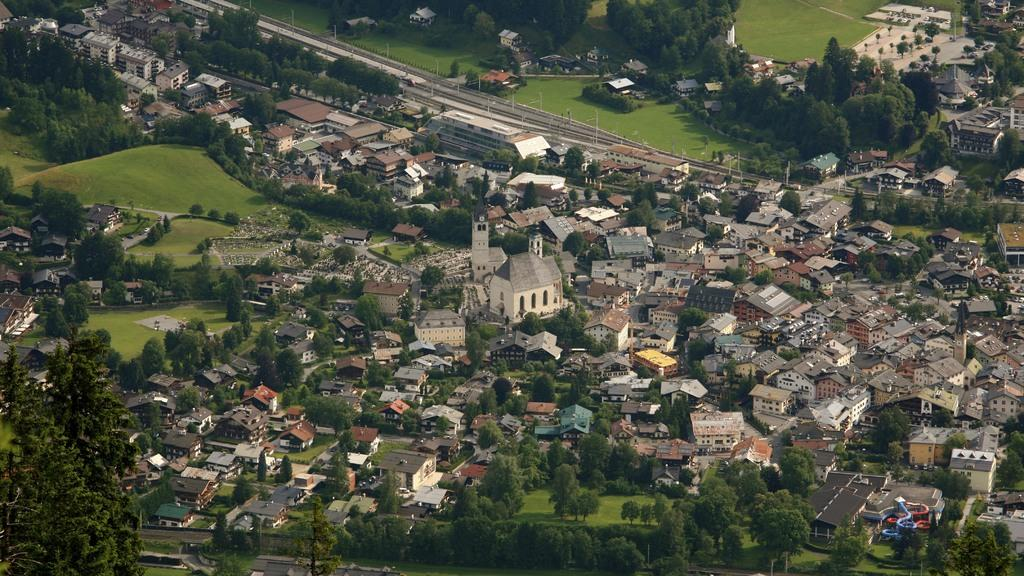What type of structures can be seen in the image? There are houses in the image. What type of vegetation is present in the image? There are trees and grass in the image. What type of pathway is visible in the image? There is a road in the image. From what perspective is the image taken? The image is taken from a top view. How many pets are sleeping on the grass in the image? There are no pets visible in the image, and it does not show any animals sleeping on the grass. 